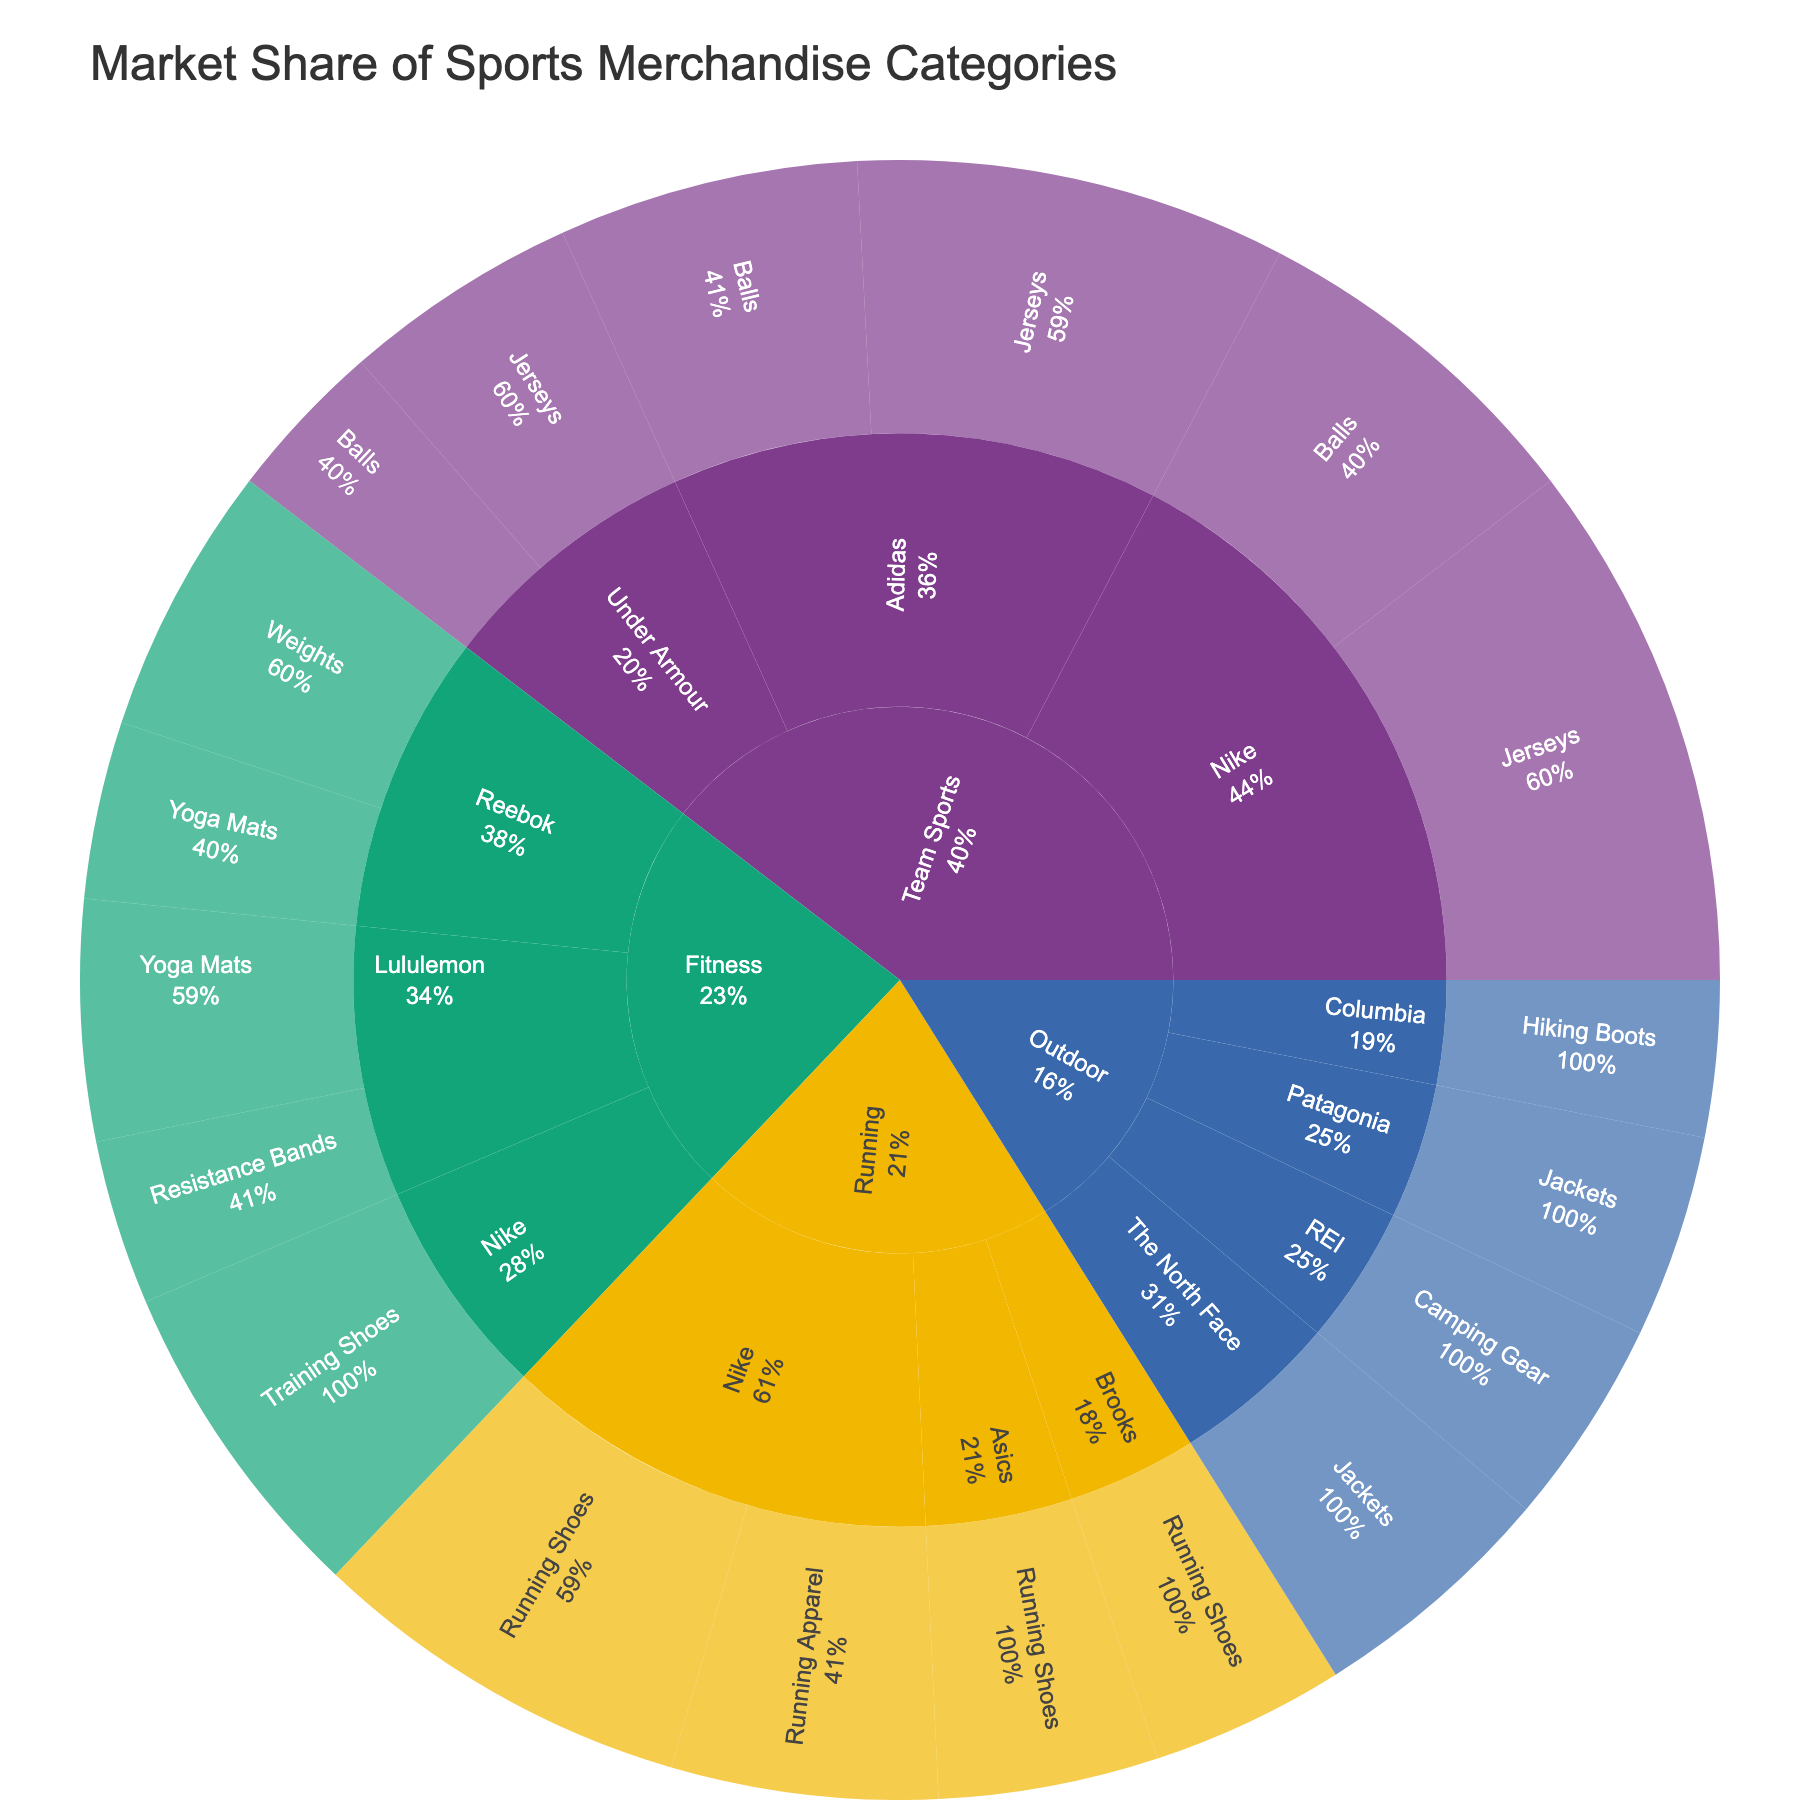Which category has the highest market share? To find the category with the highest market share, sum up the shares of each product within each category and compare them. Team Sports, Fitness, Running, and Outdoor are the categories to be considered. Visually, Team Sports seems to have the largest share.
Answer: Team Sports Which brand has the highest share under the category "Running"? Look at the breakdown of the brands in the "Running" category. Nike has shares attributed to both Running Shoes and Running Apparel, which together likely form the largest share.
Answer: Nike What percentage of the market share is occupied by Adidas in Team Sports? Within Team Sports, Adidas has two products: Jerseys (10.2%) and Balls (7.1%). Summing them up gives 10.2% + 7.1% = 17.3%.
Answer: 17.3% How does the market share of Nike's Running Shoes compare to the total market share of Reebok? Compare the percentage of Nike's Running Shoes (9.1%) with the total of Reebok's shares (Weights: 6.4%, Yoga Mats: 4.2% => 6.4% + 4.2% = 10.6%). Nike's Running Shoes are slightly lower than Reebok's total.
Answer: Less What is the total market share of Yoga Mats across all brands? Add the shares of Yoga Mats from both Reebok and Lululemon: Reebok (4.2%) + Lululemon (5.7%) = 9.9%.
Answer: 9.9% Compare the market share of Nike in Team Sports versus Fitness. Nike's share in Team Sports is Jerseys (12.5%) + Balls (8.3%) = 20.8%. In Fitness, Nike has Training Shoes (7.8%). Comparing both, Nike has a higher share in Team Sports.
Answer: Higher in Team Sports What is the market share of Under Armour's Jerseys compared to its Balls? In Team Sports, Under Armour's Jerseys have a share of 5.6%, and Balls have a share of 3.8%. Jerseys have a higher share.
Answer: Higher for Jerseys Which product under Outdoor category has the lowest market share? Look at the breakdown of products under the Outdoor category. Columbia's Hiking Boots have the lowest with 3.7%.
Answer: Hiking Boots How many brands contribute to the Fitness category? Count the distinct brands listed under the Fitness category. They include Reebok, Lululemon, and Nike, totaling 3 brands.
Answer: 3 What's the combined market share for all products under Lululemon? Lululemon has Yoga Mats (5.7%) and Resistance Bands (3.9%). Summing these, 5.7% + 3.9% = 9.6%.
Answer: 9.6% 